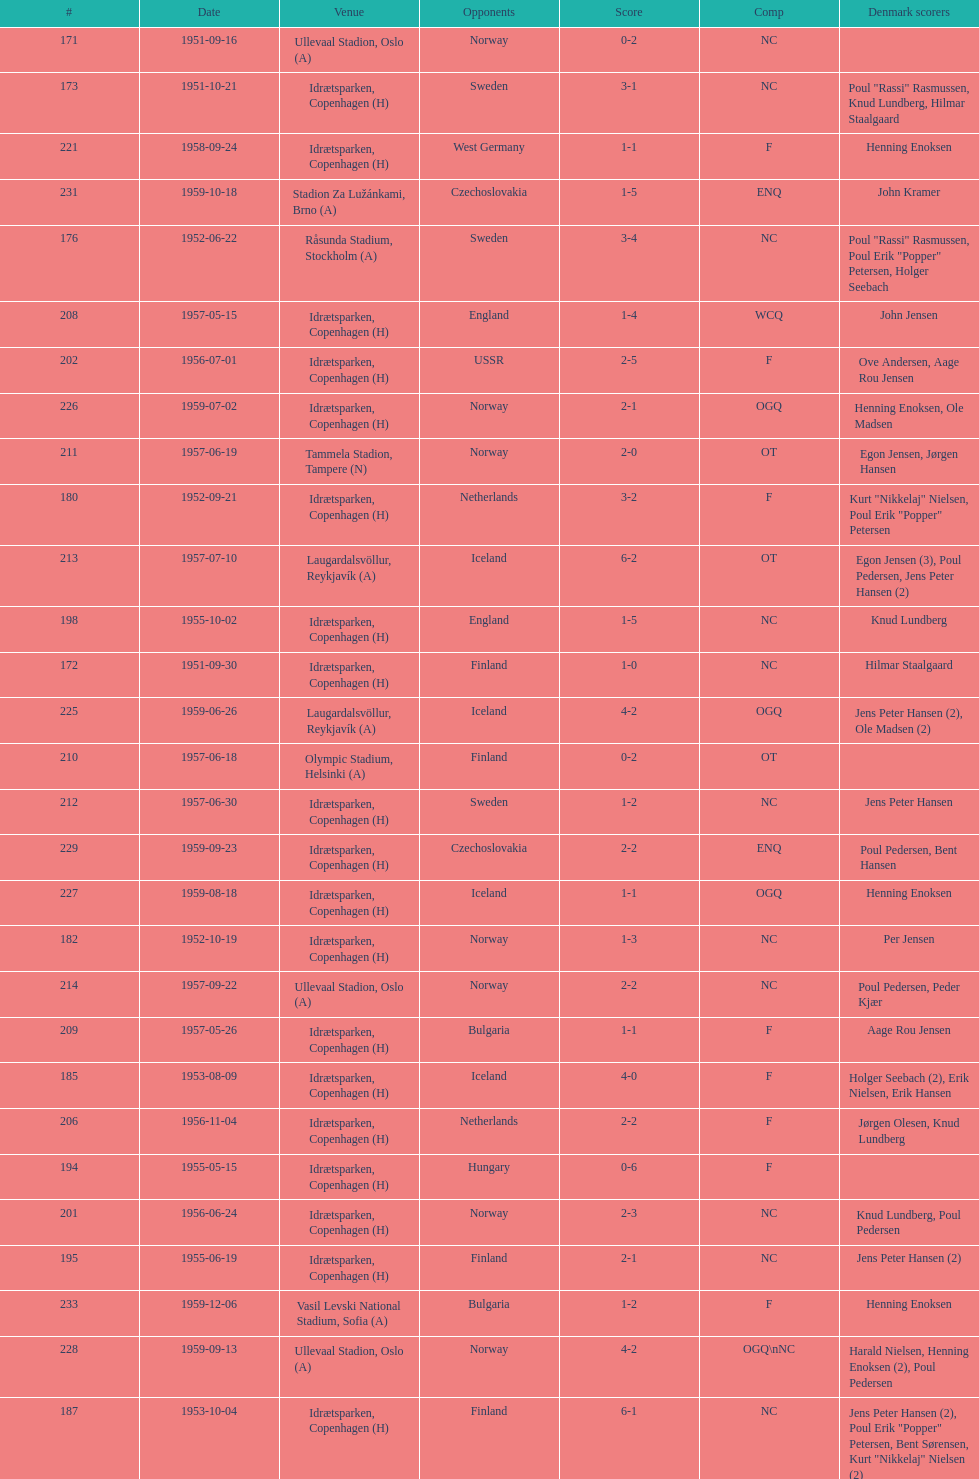What are the number of times nc appears under the comp column? 32. 